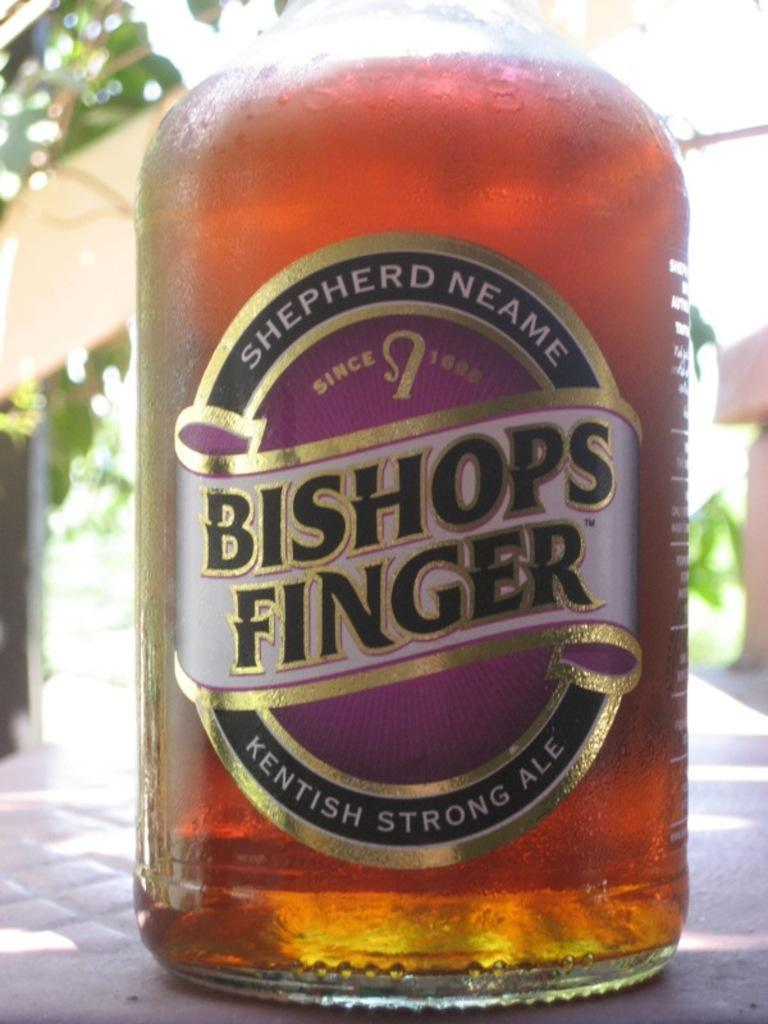Provide a one-sentence caption for the provided image. The bottom portion of a bottle of Bishops FInger ale. 